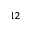Convert formula to latex. <formula><loc_0><loc_0><loc_500><loc_500>^ { 1 2 }</formula> 